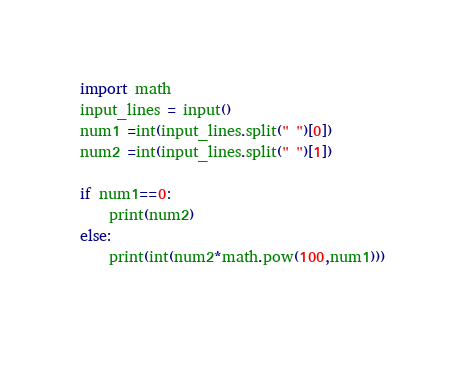<code> <loc_0><loc_0><loc_500><loc_500><_Python_>import math
input_lines = input()
num1 =int(input_lines.split(" ")[0])
num2 =int(input_lines.split(" ")[1])

if num1==0:
    print(num2)
else:
    print(int(num2*math.pow(100,num1)))
      </code> 